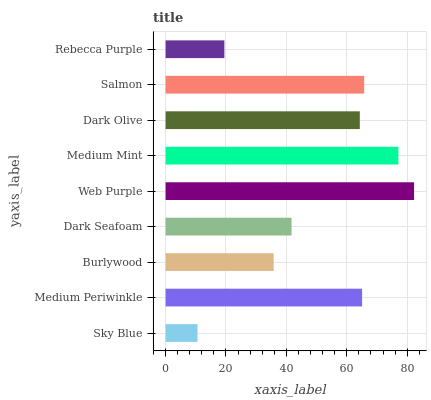Is Sky Blue the minimum?
Answer yes or no. Yes. Is Web Purple the maximum?
Answer yes or no. Yes. Is Medium Periwinkle the minimum?
Answer yes or no. No. Is Medium Periwinkle the maximum?
Answer yes or no. No. Is Medium Periwinkle greater than Sky Blue?
Answer yes or no. Yes. Is Sky Blue less than Medium Periwinkle?
Answer yes or no. Yes. Is Sky Blue greater than Medium Periwinkle?
Answer yes or no. No. Is Medium Periwinkle less than Sky Blue?
Answer yes or no. No. Is Dark Olive the high median?
Answer yes or no. Yes. Is Dark Olive the low median?
Answer yes or no. Yes. Is Salmon the high median?
Answer yes or no. No. Is Rebecca Purple the low median?
Answer yes or no. No. 